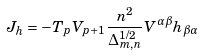<formula> <loc_0><loc_0><loc_500><loc_500>J _ { h } = - T _ { p } V _ { p + 1 } \frac { n ^ { 2 } } { \Delta _ { m , n } ^ { 1 / 2 } } V ^ { \alpha \beta } h _ { \beta \alpha }</formula> 